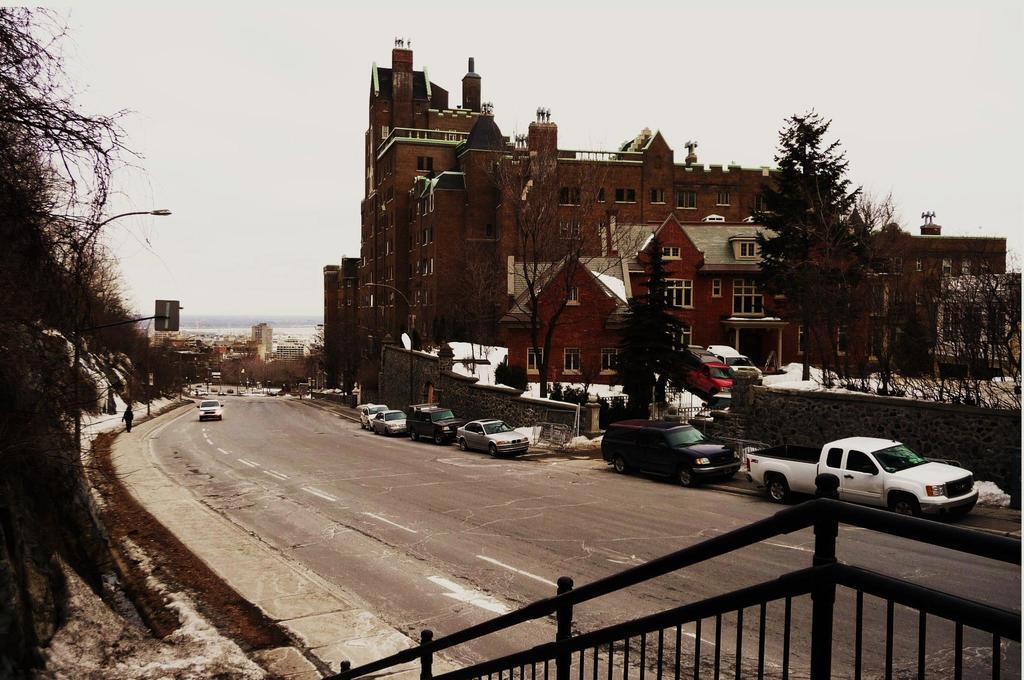How would you summarize this image in a sentence or two? In this image I see the road and I see vehicles and I see the railing over here. In the background I see number of trees and I see number of buildings and I see few poles and I see the sky. 